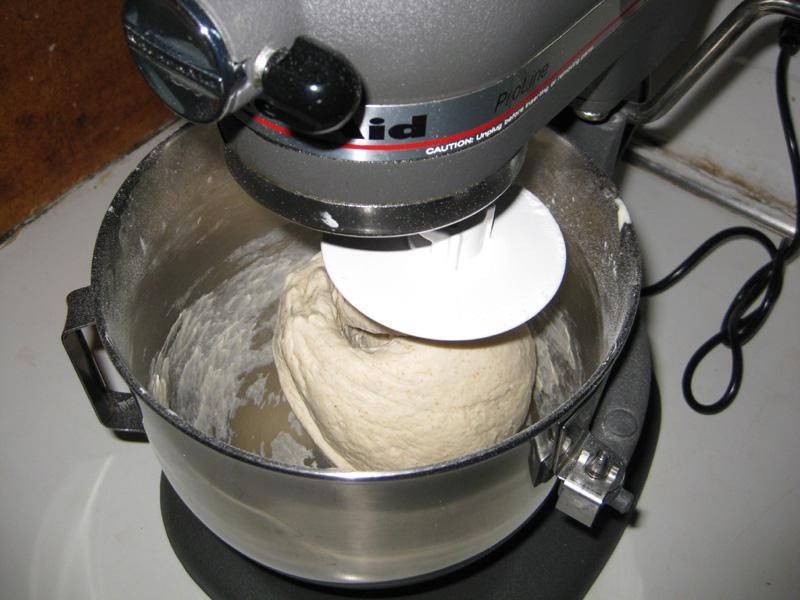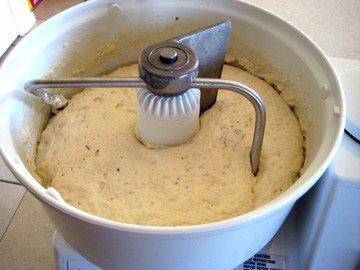The first image is the image on the left, the second image is the image on the right. Evaluate the accuracy of this statement regarding the images: "in at least one image there a bucket full of dough that is being kneed.". Is it true? Answer yes or no. Yes. The first image is the image on the left, the second image is the image on the right. For the images displayed, is the sentence "The mixer in the left image has a black power cord." factually correct? Answer yes or no. Yes. 